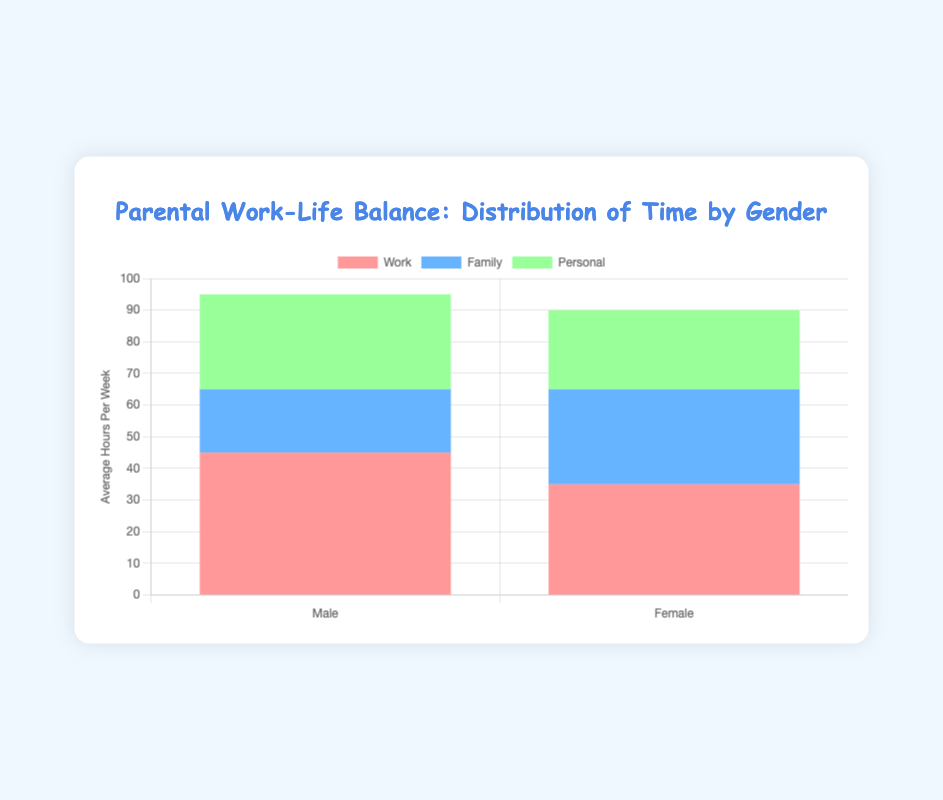How many more hours per week do males spend on work compared to females? Males spend 45 hours per week on work, while females spend 35 hours. The difference is 45 - 35 = 10 hours.
Answer: 10 What is the combined total of hours spent on family time by both genders? Males spend 20 hours per week, and females spend 30 hours on family time. The combined total is 20 + 30 = 50 hours.
Answer: 50 Which category shows the smallest difference in average hours per week between genders? For work, the difference is 10 hours. For family time, the difference is 10 hours. For personal time, the difference is 5 hours. Personal time has the smallest difference of 5 hours.
Answer: Personal What is the average weekly hours spent on personal time by both genders? Males spend 30 hours and females spend 25 hours on personal time. The average is (30 + 25) / 2 = 27.5 hours.
Answer: 27.5 Which gender spends more total hours per week combining all categories, and by how much? For males: 45 (work) + 20 (family) + 30 (personal) = 95 hours. For females: 35 (work) + 30 (family) + 25 (personal) = 90 hours. Males spend more by 95 - 90 = 5 hours.
Answer: Male, 5 What category consumes the largest portion of time for males? By examining the bar heights for males, work has the highest value at 45 hours per week.
Answer: Work How do the average hours spent on work and family time combined compare between males and females? Males: 45 (work) + 20 (family) = 65 hours. Females: 35 (work) + 30 (family) = 65 hours. Both spend the same amount of time combined.
Answer: Equal, 65 What is the total average weekly hours spent by females on all categories? Females spend 35 hours on work, 30 hours on family, and 25 hours on personal time. The total is 35 + 30 + 25 = 90 hours.
Answer: 90 How many additional hours do females spend on family time compared to males? Females spend 30 hours, and males spend 20 hours on family time. The difference is 30 - 20 = 10 hours.
Answer: 10 